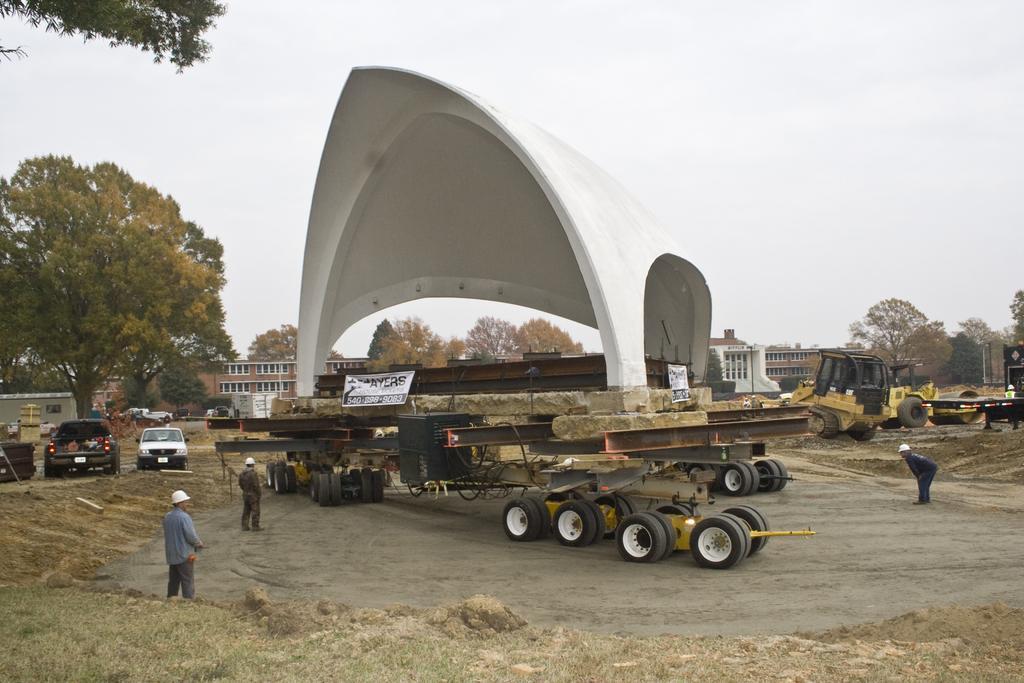In one or two sentences, can you explain what this image depicts? In this image we can see a constructive item on a carrier. In the background of the image there is a proclainer, roller. There are people standing. At the bottom of the image there is grass. There are cars. In the background of the image there are buildings, trees. At the top of the image there is sky. 